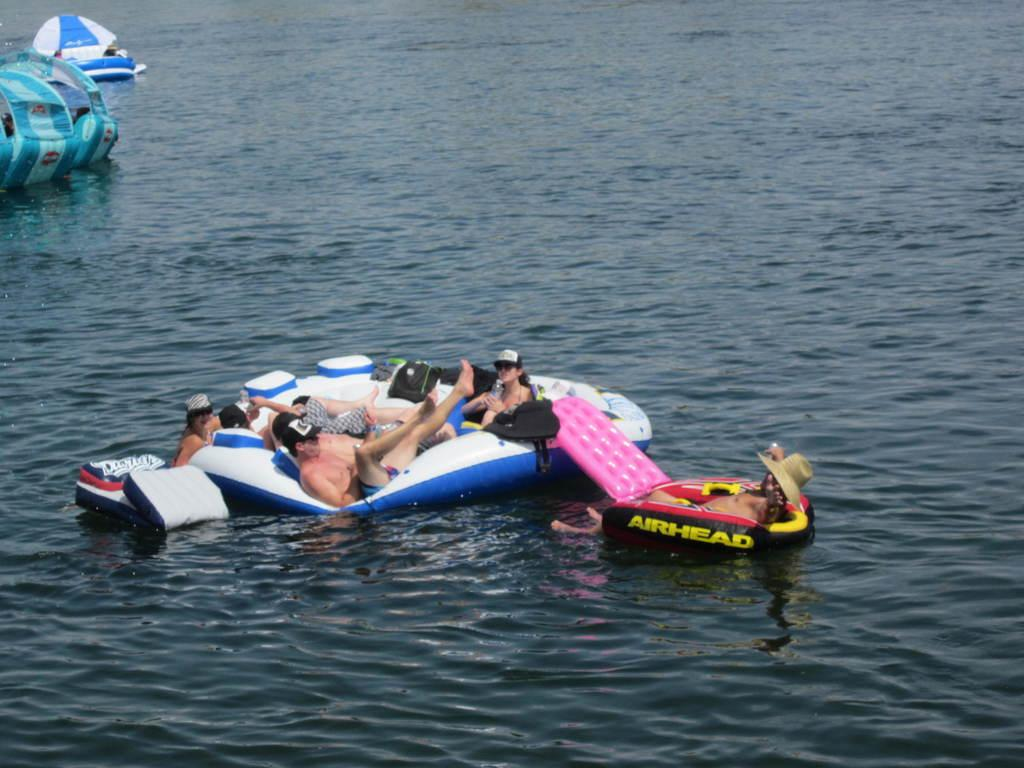<image>
Create a compact narrative representing the image presented. A woman in a sunhat is laying on an inflatable, airhead raft, next to another, larger raft, with several people inside it. 